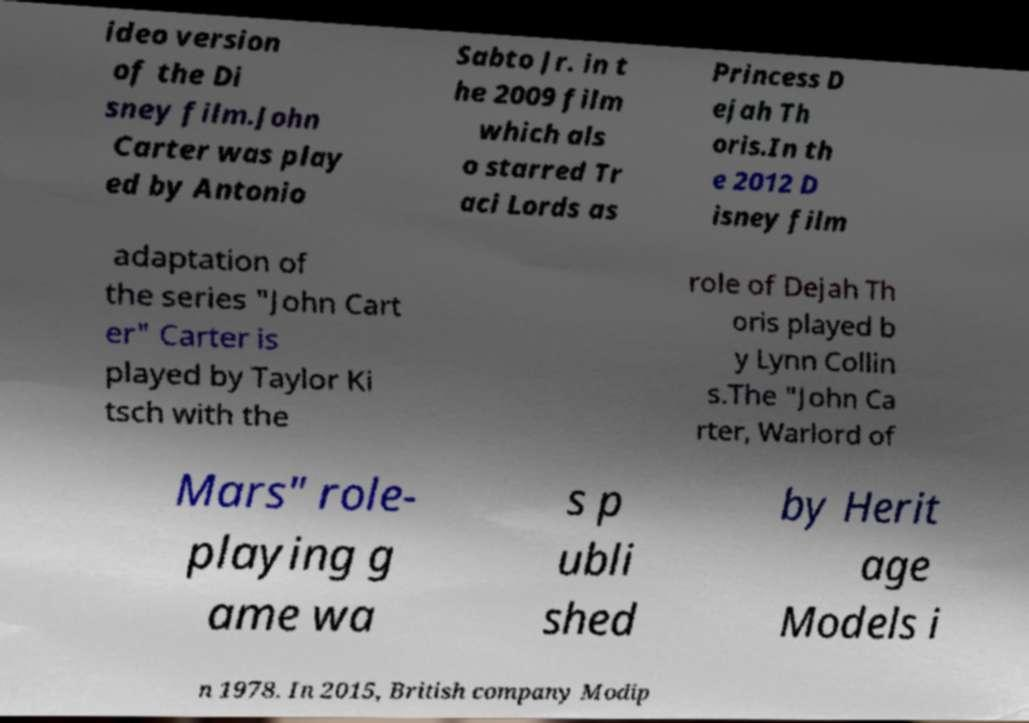Can you read and provide the text displayed in the image?This photo seems to have some interesting text. Can you extract and type it out for me? ideo version of the Di sney film.John Carter was play ed by Antonio Sabto Jr. in t he 2009 film which als o starred Tr aci Lords as Princess D ejah Th oris.In th e 2012 D isney film adaptation of the series "John Cart er" Carter is played by Taylor Ki tsch with the role of Dejah Th oris played b y Lynn Collin s.The "John Ca rter, Warlord of Mars" role- playing g ame wa s p ubli shed by Herit age Models i n 1978. In 2015, British company Modip 